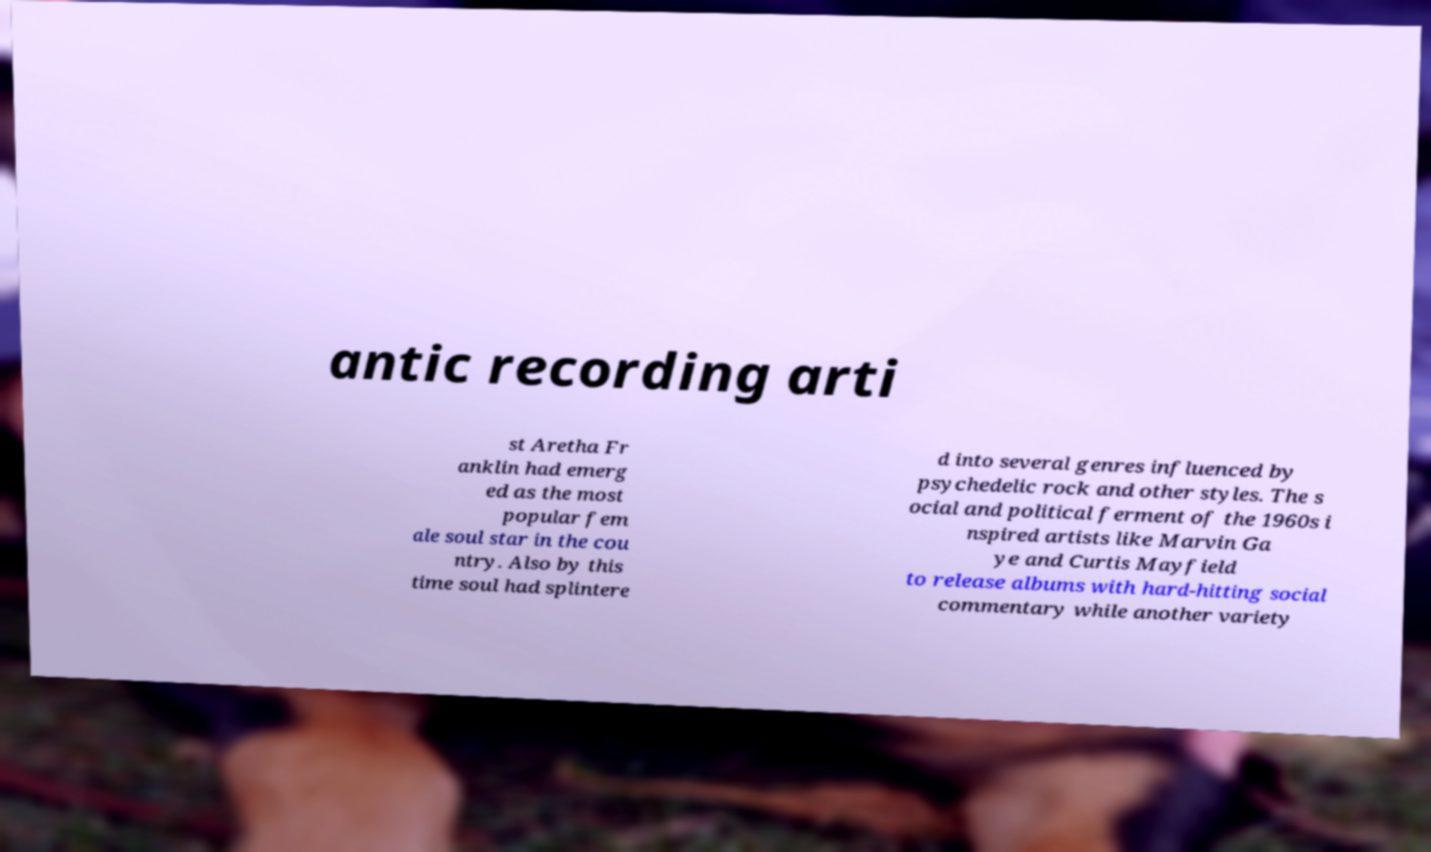Please read and relay the text visible in this image. What does it say? antic recording arti st Aretha Fr anklin had emerg ed as the most popular fem ale soul star in the cou ntry. Also by this time soul had splintere d into several genres influenced by psychedelic rock and other styles. The s ocial and political ferment of the 1960s i nspired artists like Marvin Ga ye and Curtis Mayfield to release albums with hard-hitting social commentary while another variety 